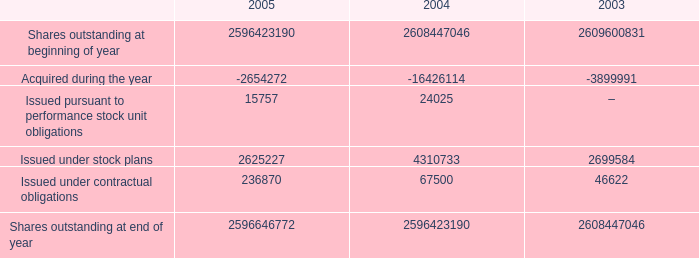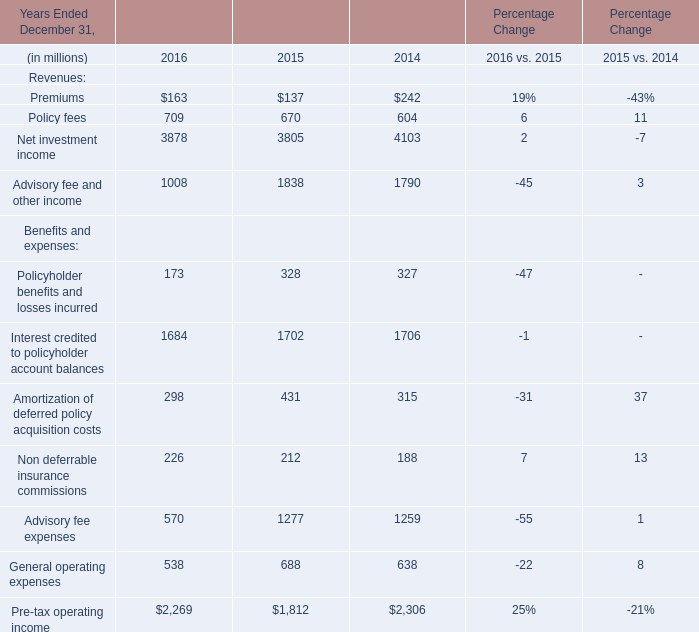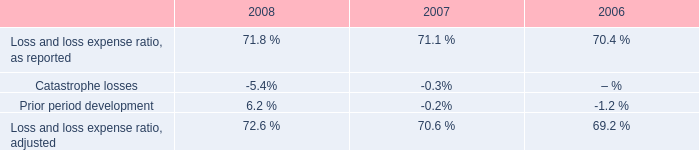What's the sum of Revenues in the range of 1000 and 4000 in 2016? (in dollars in millions) 
Computations: (3878 + 1008)
Answer: 4886.0. 